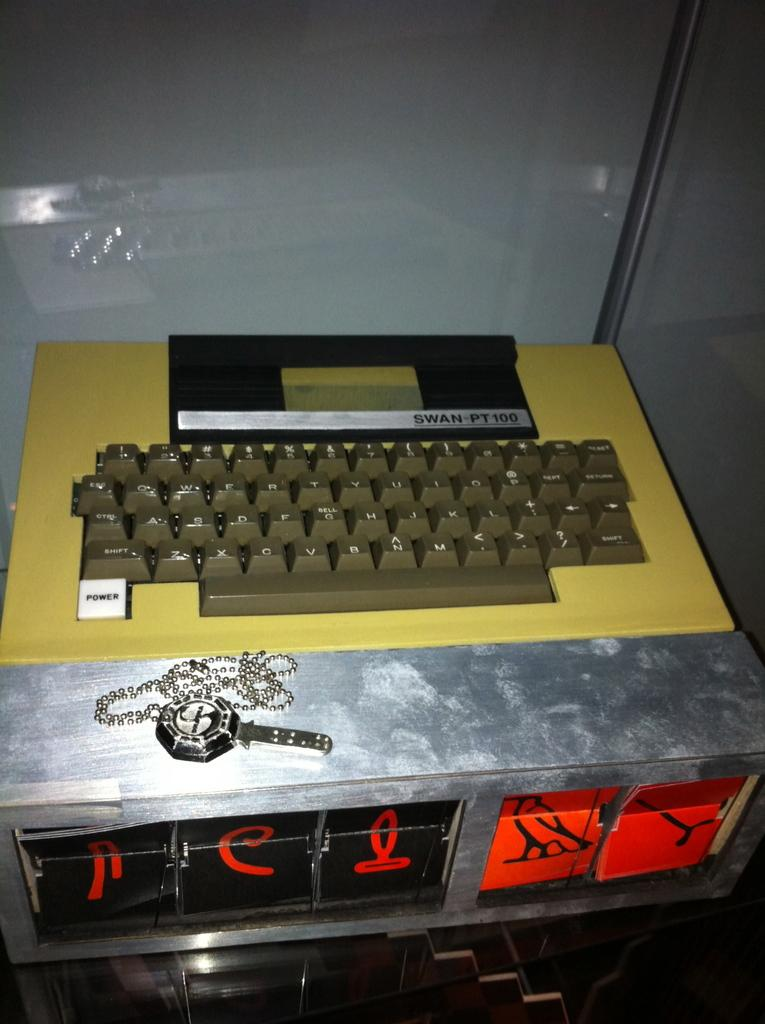<image>
Present a compact description of the photo's key features. A Swan Pt 100 keyboard that has a power on button built into a metal box. 